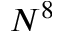<formula> <loc_0><loc_0><loc_500><loc_500>N ^ { 8 }</formula> 